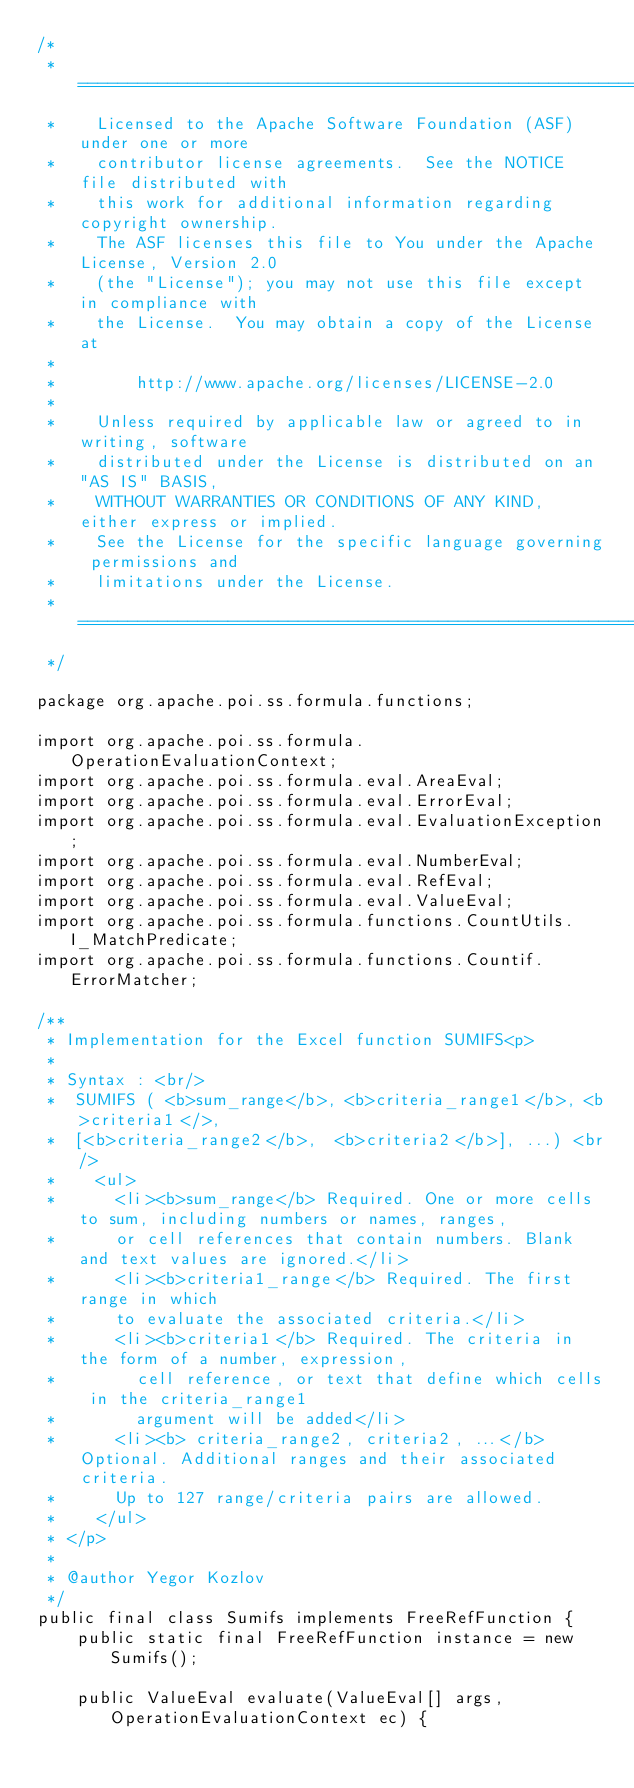Convert code to text. <code><loc_0><loc_0><loc_500><loc_500><_Java_>/*
 *  ====================================================================
 *    Licensed to the Apache Software Foundation (ASF) under one or more
 *    contributor license agreements.  See the NOTICE file distributed with
 *    this work for additional information regarding copyright ownership.
 *    The ASF licenses this file to You under the Apache License, Version 2.0
 *    (the "License"); you may not use this file except in compliance with
 *    the License.  You may obtain a copy of the License at
 *
 *        http://www.apache.org/licenses/LICENSE-2.0
 *
 *    Unless required by applicable law or agreed to in writing, software
 *    distributed under the License is distributed on an "AS IS" BASIS,
 *    WITHOUT WARRANTIES OR CONDITIONS OF ANY KIND, either express or implied.
 *    See the License for the specific language governing permissions and
 *    limitations under the License.
 * ====================================================================
 */

package org.apache.poi.ss.formula.functions;

import org.apache.poi.ss.formula.OperationEvaluationContext;
import org.apache.poi.ss.formula.eval.AreaEval;
import org.apache.poi.ss.formula.eval.ErrorEval;
import org.apache.poi.ss.formula.eval.EvaluationException;
import org.apache.poi.ss.formula.eval.NumberEval;
import org.apache.poi.ss.formula.eval.RefEval;
import org.apache.poi.ss.formula.eval.ValueEval;
import org.apache.poi.ss.formula.functions.CountUtils.I_MatchPredicate;
import org.apache.poi.ss.formula.functions.Countif.ErrorMatcher;

/**
 * Implementation for the Excel function SUMIFS<p>
 *
 * Syntax : <br/>
 *  SUMIFS ( <b>sum_range</b>, <b>criteria_range1</b>, <b>criteria1</>,
 *  [<b>criteria_range2</b>,  <b>criteria2</b>], ...) <br/>
 *    <ul>
 *      <li><b>sum_range</b> Required. One or more cells to sum, including numbers or names, ranges,
 *      or cell references that contain numbers. Blank and text values are ignored.</li>
 *      <li><b>criteria1_range</b> Required. The first range in which
 *      to evaluate the associated criteria.</li>
 *      <li><b>criteria1</b> Required. The criteria in the form of a number, expression,
 *        cell reference, or text that define which cells in the criteria_range1
 *        argument will be added</li>
 *      <li><b> criteria_range2, criteria2, ...</b>    Optional. Additional ranges and their associated criteria.
 *      Up to 127 range/criteria pairs are allowed.
 *    </ul>
 * </p>
 *
 * @author Yegor Kozlov
 */
public final class Sumifs implements FreeRefFunction {
    public static final FreeRefFunction instance = new Sumifs();

	public ValueEval evaluate(ValueEval[] args, OperationEvaluationContext ec) {</code> 